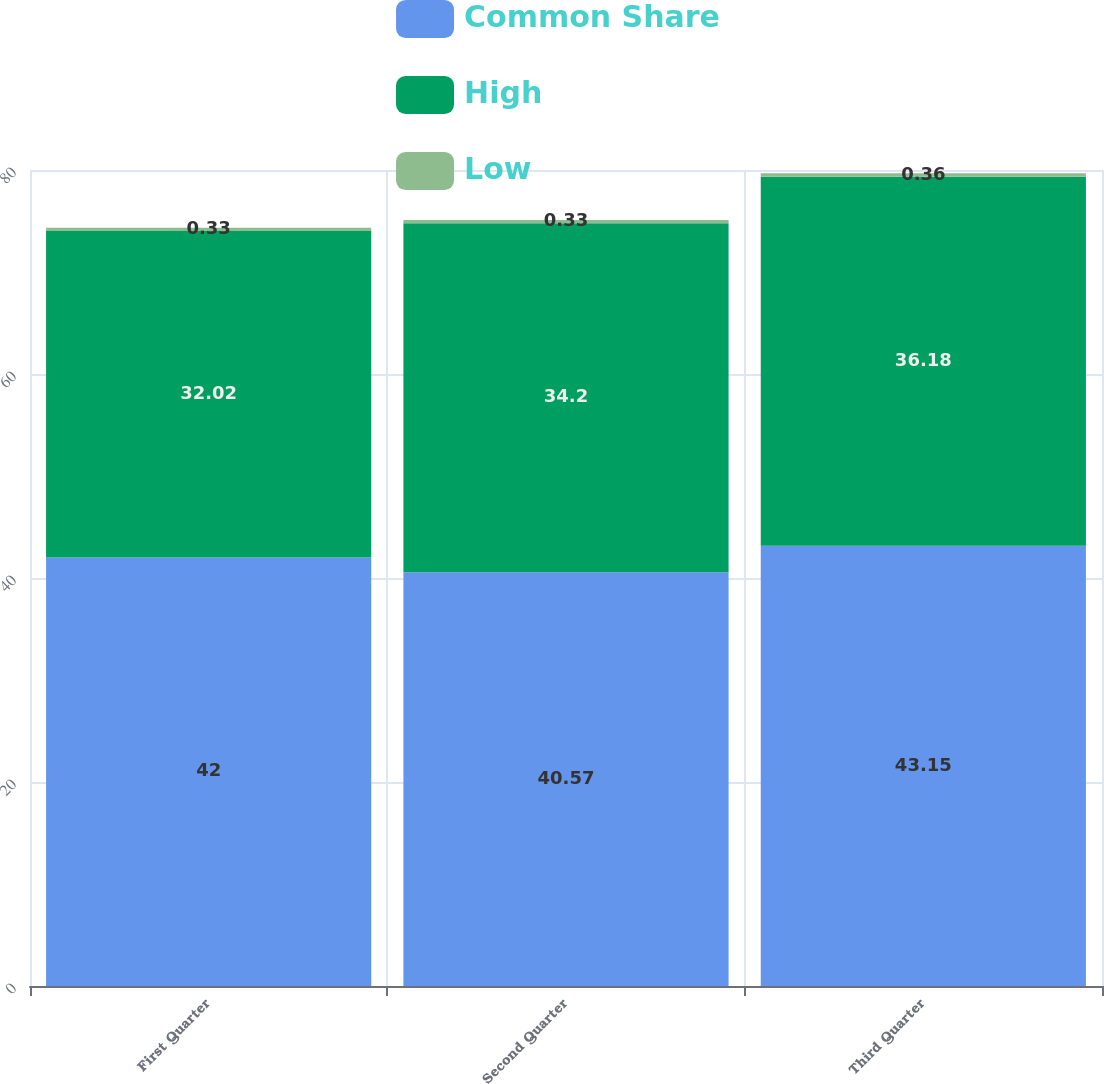<chart> <loc_0><loc_0><loc_500><loc_500><stacked_bar_chart><ecel><fcel>First Quarter<fcel>Second Quarter<fcel>Third Quarter<nl><fcel>Common Share<fcel>42<fcel>40.57<fcel>43.15<nl><fcel>High<fcel>32.02<fcel>34.2<fcel>36.18<nl><fcel>Low<fcel>0.33<fcel>0.33<fcel>0.36<nl></chart> 